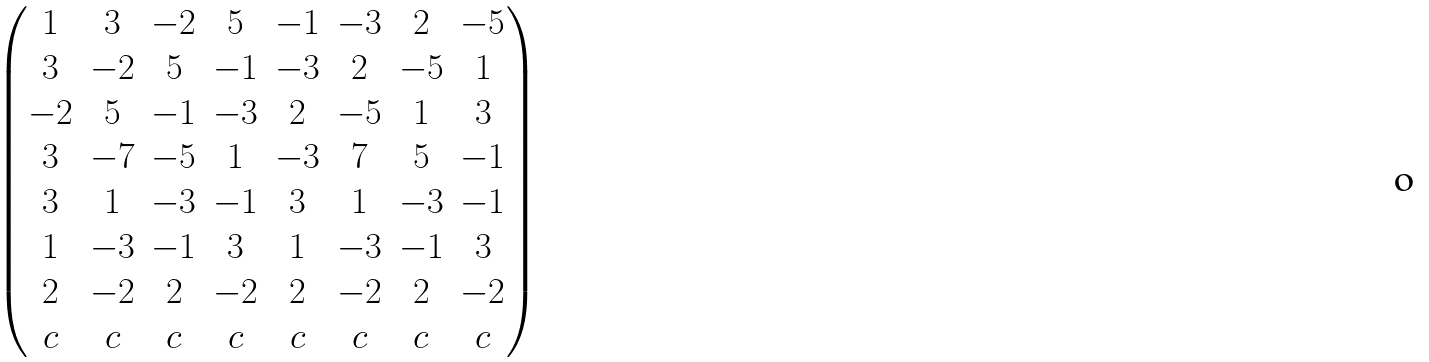Convert formula to latex. <formula><loc_0><loc_0><loc_500><loc_500>\begin{pmatrix} 1 & 3 & - 2 & 5 & - 1 & - 3 & 2 & - 5 \\ 3 & - 2 & 5 & - 1 & - 3 & 2 & - 5 & 1 \\ - 2 & 5 & - 1 & - 3 & 2 & - 5 & 1 & 3 \\ 3 & - 7 & - 5 & 1 & - 3 & 7 & 5 & - 1 \\ 3 & 1 & - 3 & - 1 & 3 & 1 & - 3 & - 1 \\ 1 & - 3 & - 1 & 3 & 1 & - 3 & - 1 & 3 \\ 2 & - 2 & 2 & - 2 & 2 & - 2 & 2 & - 2 \\ c & c & c & c & c & c & c & c \end{pmatrix}</formula> 